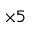<formula> <loc_0><loc_0><loc_500><loc_500>\times 5</formula> 